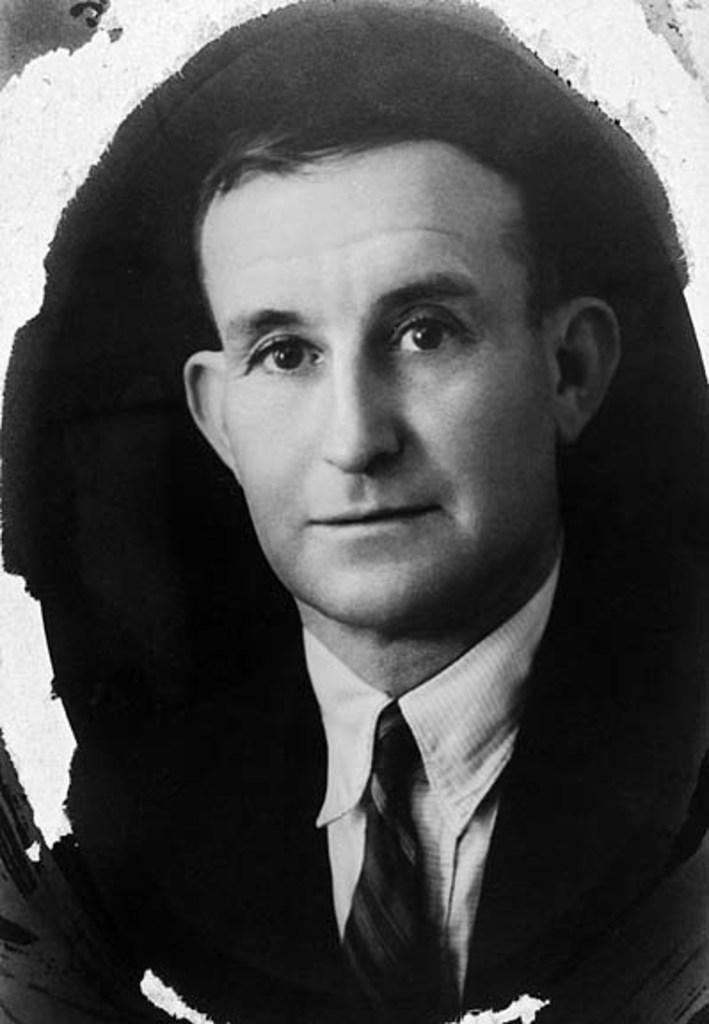What is the main subject of the image? There is a man in the image. What is the man wearing in the image? The man is wearing a coat and a tie. What type of needle is the man using in the image? There is no needle present in the image. What is the man feeling ashamed about in the image? There is no indication of shame or any negative emotion in the image. 